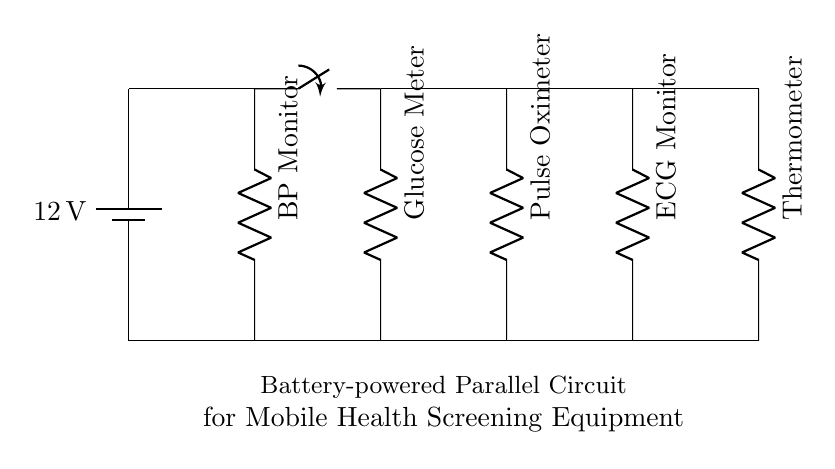What is the voltage of the battery in this circuit? The circuit shows a battery labeled with a voltage of 12 volts. This indicates the potential difference provided by the battery to power the connected components.
Answer: 12 volts How many branches are provided in this parallel circuit? Observing the circuit, there are five branches emanating from the main horizontal line, which connect different devices. Each device is on its own branch, indicating a total of five branches in the circuit.
Answer: Five What device is labeled as the first branch from the left? The first branch connects to a component labeled as a BP Monitor. This is visible due to its position at the first vertical drop from the horizontal line.
Answer: BP Monitor Which device appears last in the sequence of branches? The last branch on the right connects to a device labeled as a Thermometer. This is established by counting the branches from left to right and identifying the last component in the series.
Answer: Thermometer What type of circuit is illustrated in this diagram? The diagram represents a parallel circuit because multiple components are connected alongside each other directly to the same voltage source, allowing each device to operate independently.
Answer: Parallel circuit What is the function of the switch in this circuit? The switch allows the user to control the flow of current within the circuit. When opened, it interrupts the circuit; when closed, it allows current to flow to all branches simultaneously.
Answer: Control current flow Which device is connected to the second branch? The second branch holds a Glucose Meter as indicated by the label placed vertically along this branch. This placement allows for easy identification of the component on that parallel line.
Answer: Glucose Meter 